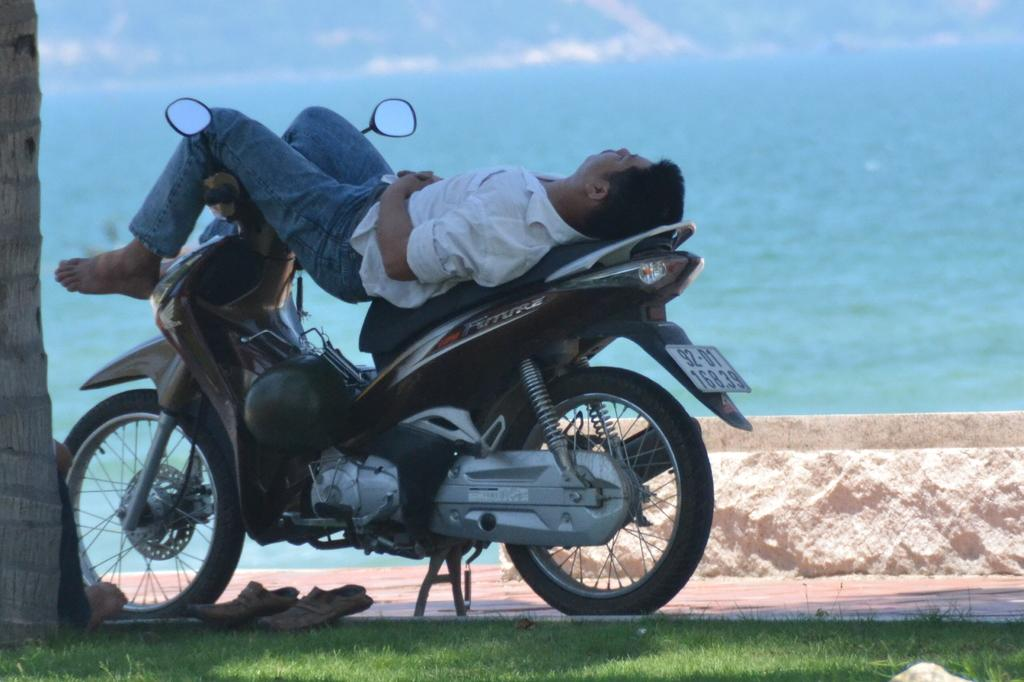What is visible in the image? There is water and grass visible in the image. What is the man doing in the image? The man is laying on a scooter in the image. What type of board is the man using to write on the grass in the image? There is no board or writing activity present in the image. What color is the chalk the man is using to mark the territory in the image? There is no chalk or marking of territory in the image. 